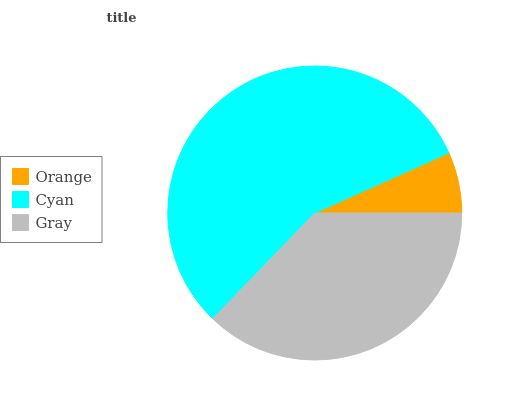Is Orange the minimum?
Answer yes or no. Yes. Is Cyan the maximum?
Answer yes or no. Yes. Is Gray the minimum?
Answer yes or no. No. Is Gray the maximum?
Answer yes or no. No. Is Cyan greater than Gray?
Answer yes or no. Yes. Is Gray less than Cyan?
Answer yes or no. Yes. Is Gray greater than Cyan?
Answer yes or no. No. Is Cyan less than Gray?
Answer yes or no. No. Is Gray the high median?
Answer yes or no. Yes. Is Gray the low median?
Answer yes or no. Yes. Is Orange the high median?
Answer yes or no. No. Is Orange the low median?
Answer yes or no. No. 